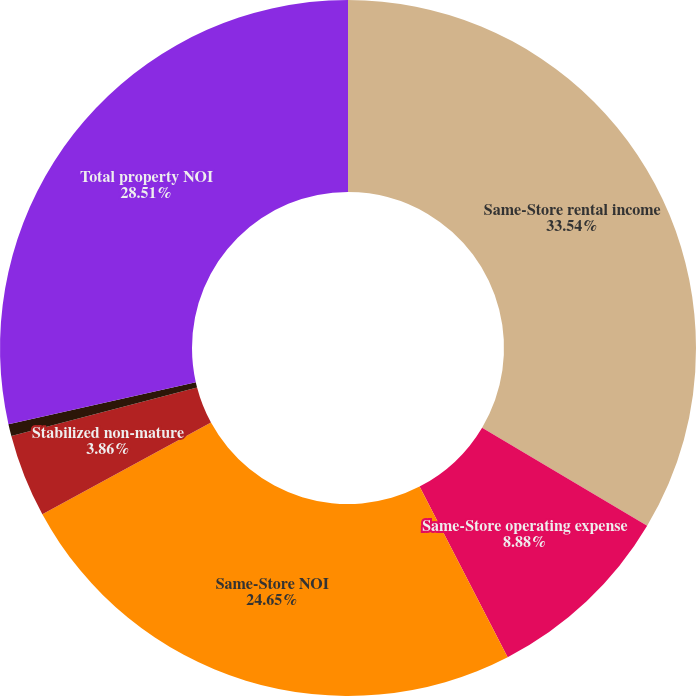<chart> <loc_0><loc_0><loc_500><loc_500><pie_chart><fcel>Same-Store rental income<fcel>Same-Store operating expense<fcel>Same-Store NOI<fcel>Stabilized non-mature<fcel>Sold and held for disposition<fcel>Total property NOI<nl><fcel>33.53%<fcel>8.88%<fcel>24.65%<fcel>3.86%<fcel>0.56%<fcel>28.51%<nl></chart> 